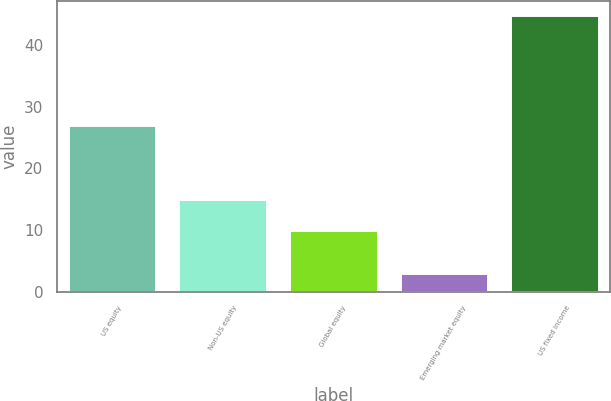<chart> <loc_0><loc_0><loc_500><loc_500><bar_chart><fcel>US equity<fcel>Non-US equity<fcel>Global equity<fcel>Emerging market equity<fcel>US fixed income<nl><fcel>27<fcel>15<fcel>10<fcel>3<fcel>45<nl></chart> 